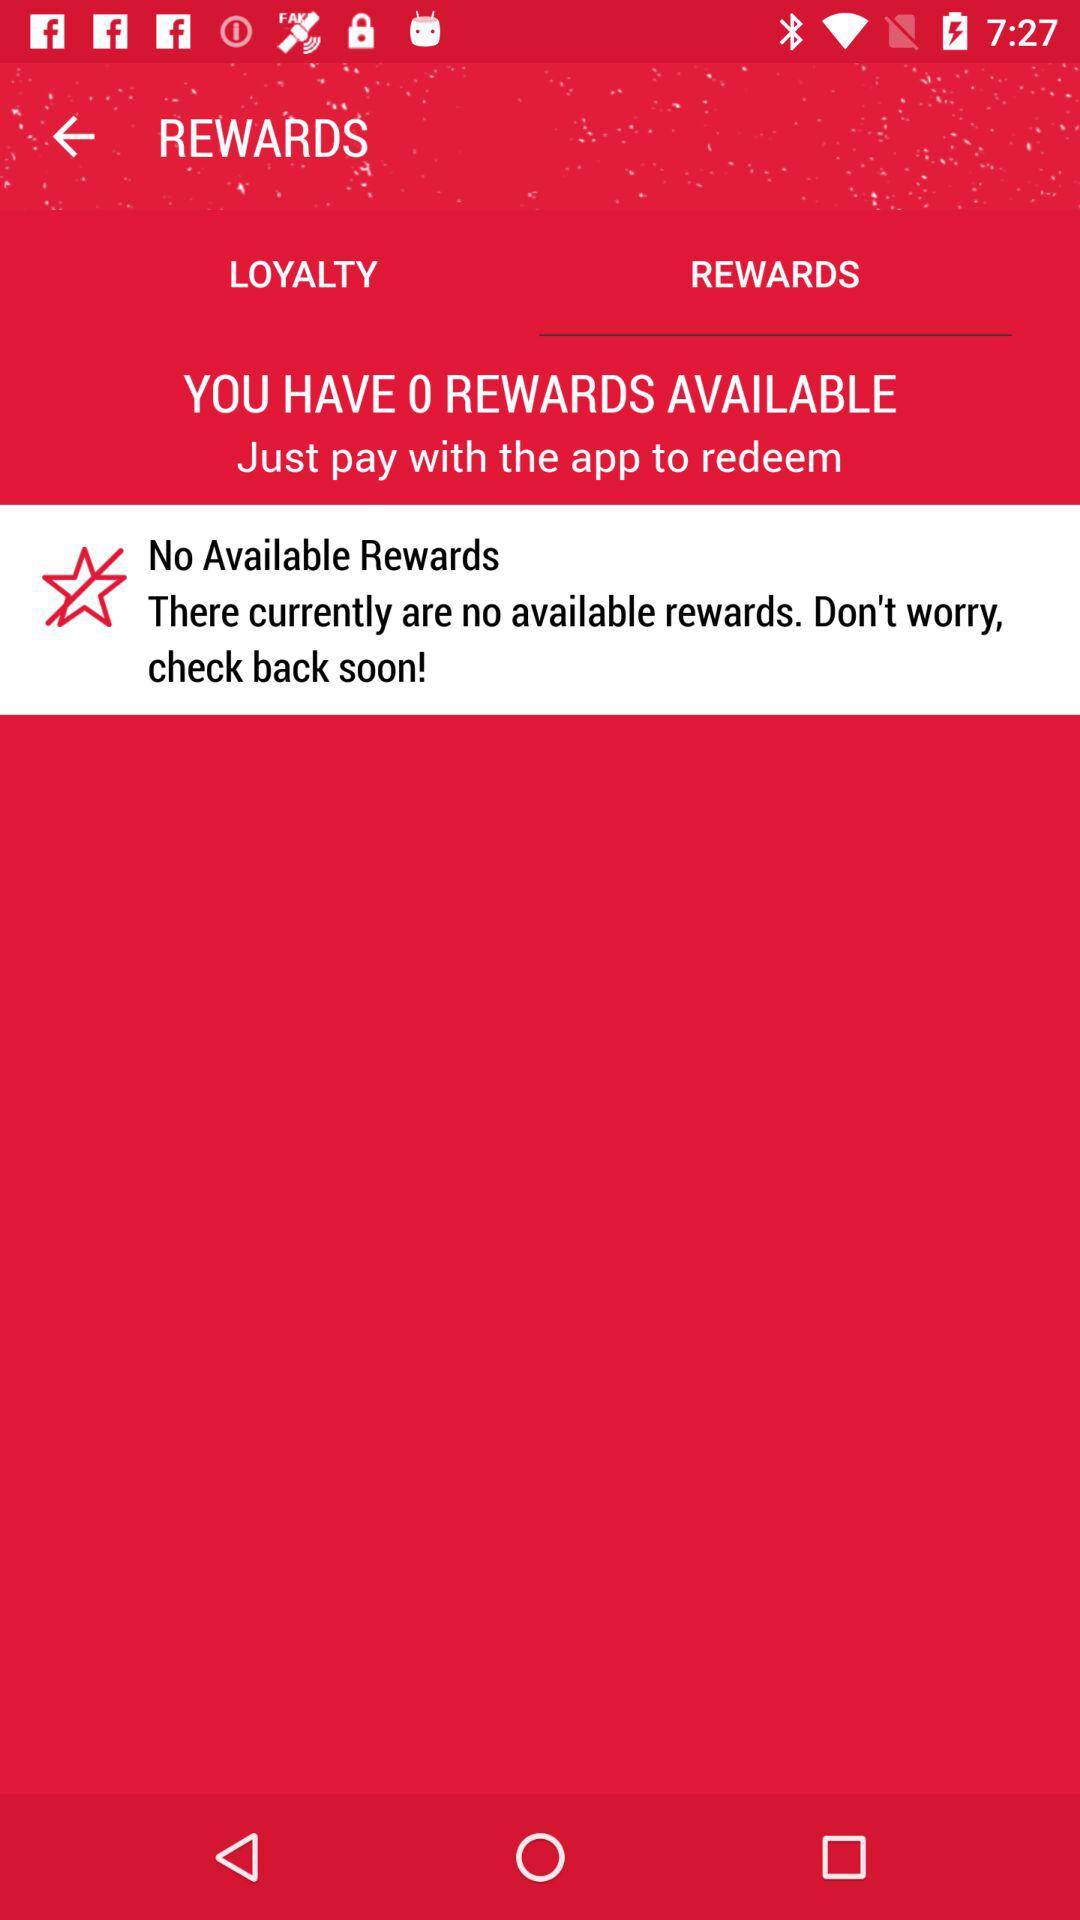How many rewards does the user have?
Answer the question using a single word or phrase. 0 